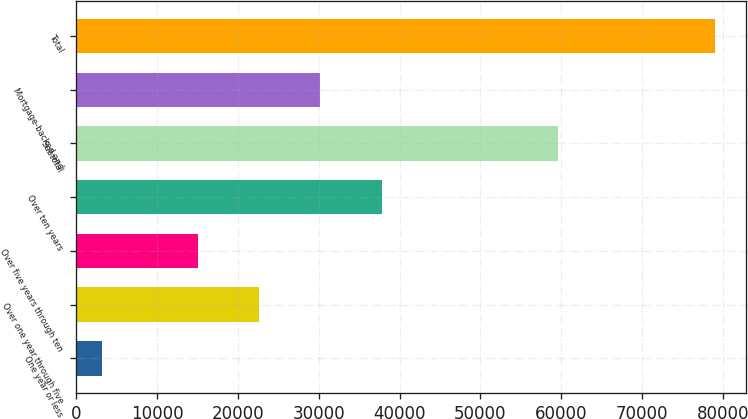<chart> <loc_0><loc_0><loc_500><loc_500><bar_chart><fcel>One year or less<fcel>Over one year through five<fcel>Over five years through ten<fcel>Over ten years<fcel>Subtotal<fcel>Mortgage-backed and<fcel>Total<nl><fcel>3206<fcel>22618.2<fcel>15041<fcel>37772.6<fcel>59576<fcel>30195.4<fcel>78978<nl></chart> 